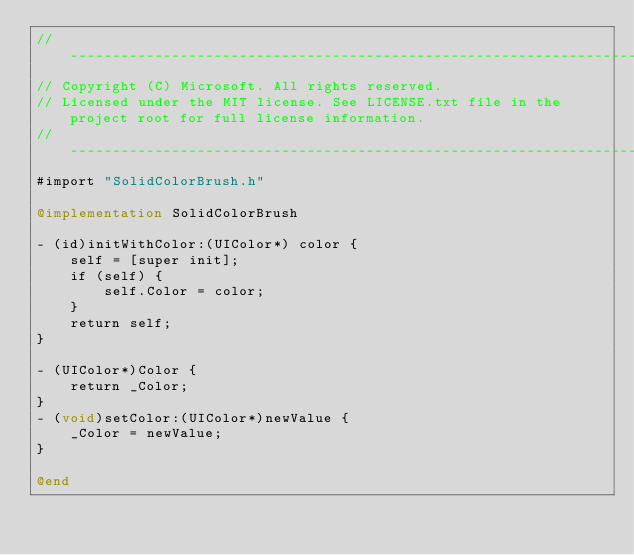Convert code to text. <code><loc_0><loc_0><loc_500><loc_500><_ObjectiveC_>//-------------------------------------------------------------------------------------------------------
// Copyright (C) Microsoft. All rights reserved.
// Licensed under the MIT license. See LICENSE.txt file in the project root for full license information.
//-------------------------------------------------------------------------------------------------------
#import "SolidColorBrush.h"

@implementation SolidColorBrush

- (id)initWithColor:(UIColor*) color {
    self = [super init];
    if (self) {
        self.Color = color;
    }
    return self;
}

- (UIColor*)Color {
    return _Color;
}
- (void)setColor:(UIColor*)newValue {
    _Color = newValue;
}

@end
</code> 